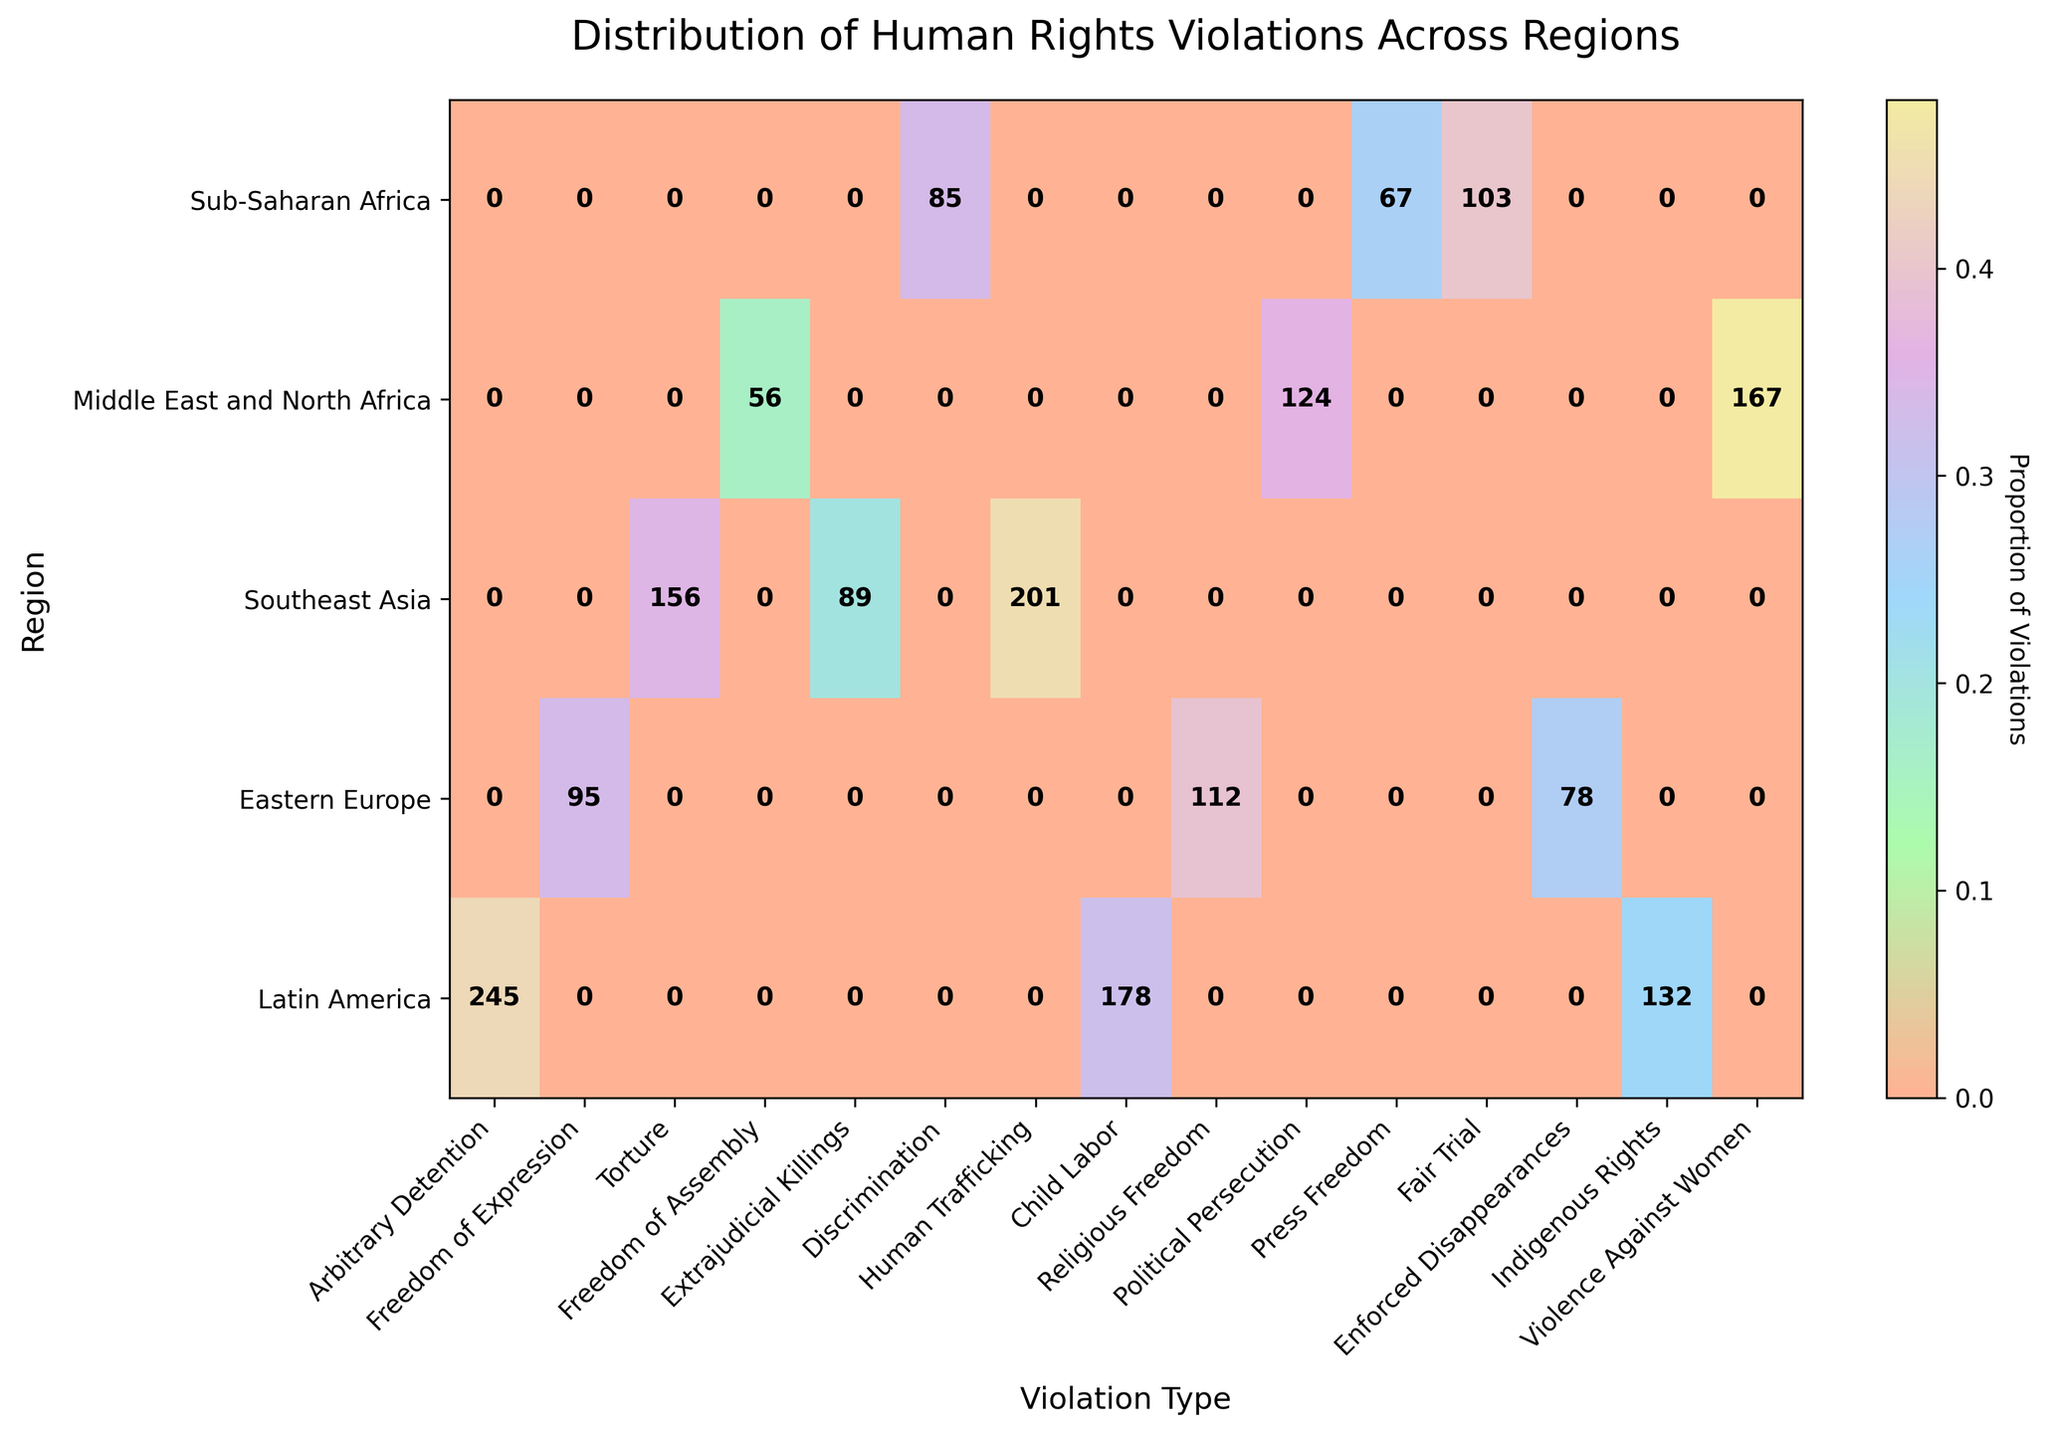What regions and violation types are represented in the plot? To understand the scope of the plot, we note that the x-axis lists the types of human rights violations while the y-axis lists the regions. We see these labels from the data provided.
Answer: Sub-Saharan Africa, Middle East and North Africa, Southeast Asia, Eastern Europe, Latin America; Arbitrary Detention, Freedom of Expression, Torture, Freedom of Assembly, Extrajudicial Killings, Discrimination, Human Trafficking, Child Labor, Religious Freedom, Political Persecution, Press Freedom, Fair Trial, Enforced Disappearances, Indigenous Rights, Violence Against Women Which region has the highest count of any single type of human rights violation? Looking at the plot, the highest counts are represented by the darkest shades of color and can be cross-referenced with the numerical labels within the cells. By inspecting this, we find the highest single count.
Answer: Sub-Saharan Africa with Arbitrary Detention (245) What is the total count of human rights violations in Southeast Asia? We add together the counts of violations in each type for Southeast Asia. According to the plot, these counts are 112 (Human Trafficking), 95 (Child Labor), and 78 (Religious Freedom). Adding these values gives the total.
Answer: 285 Which violation type in Eastern Europe has the lowest count? By examining the bars specific to Eastern Europe in the plot, the lowest value among Political Persecution (67), Press Freedom (103), and Fair Trial (85) is identified.
Answer: Political Persecution Compare the count of Torture in Sub-Saharan Africa to Extrajudicial Killings in Middle East and North Africa. Which has a higher count? From the plot's text labels, we note the value for Torture in Sub-Saharan Africa (132) and for Extrajudicial Killings in Middle East and North Africa (89). Comparing these values shows which is higher.
Answer: Torture in Sub-Saharan Africa How is the data normalized in the plot, and how does it affect the interpretation? The plot normalizes the counts by proportion, meaning the counts of violations in each region are divided by the total counts in that region to give a proportion. This affects interpretation by representing the relative weight rather than absolute counts.
Answer: Proportional normalization Which region has the most even distribution of violation types, and how can you tell? An even distribution would mean all the cells of a region have similar shading intensity. By visually inspecting the plot, we note the region where cells have similar shading.
Answer: Southeast Asia Determine the average count of human rights violations for Latin America across all violation types represented in the region. The counts for Latin America are 56 (Enforced Disappearances), 124 (Indigenous Rights), and 167 (Violence Against Women). Adding these and dividing by the number of types (3) gives the average.
Answer: (56 + 124 + 167) / 3 = 115.67 What violation type is unique to only one region, if any? By checking the violation types and their occurrences across different regions in the plot, we see if any violation type is only represented in one region.
Answer: Arbitrary Detention (only in Sub-Saharan Africa) Compare the proportion of Freedom of Expression violations between Sub-Saharan Africa and Middle East and North Africa. Which region has a higher proportion? The text annotations on the plot allow us to read the exact counts for Freedom of Expression in Sub-Saharan Africa (178) and compare it to the counts for other violations in the same regions. The proportions are derived and compared accordingly.
Answer: Sub-Saharan Africa (178 / 555) > Middle East and North Africa (201 / 446) 